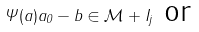Convert formula to latex. <formula><loc_0><loc_0><loc_500><loc_500>\Psi ( a ) a _ { 0 } - b \in \mathcal { M } + I _ { j } \text { or}</formula> 